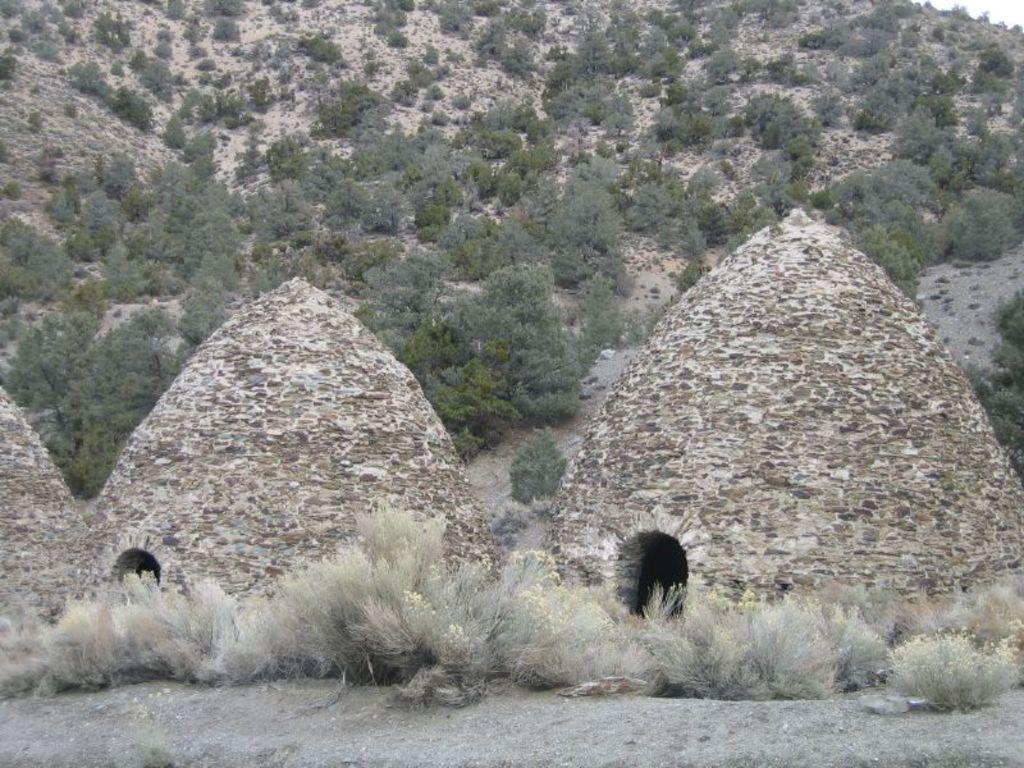What structures are present in the image? There are charcoal kilns in the image. What can be seen beneath the structures? The ground is visible in the image. What type of vegetation is present in the image? There is grass and plants in the image. How does the bike get through the thick mist in the image? There is no bike or mist present in the image. What type of jam is being made from the plants in the image? There is no jam-making process depicted in the image, and the plants are not specified as being used for jam production. 